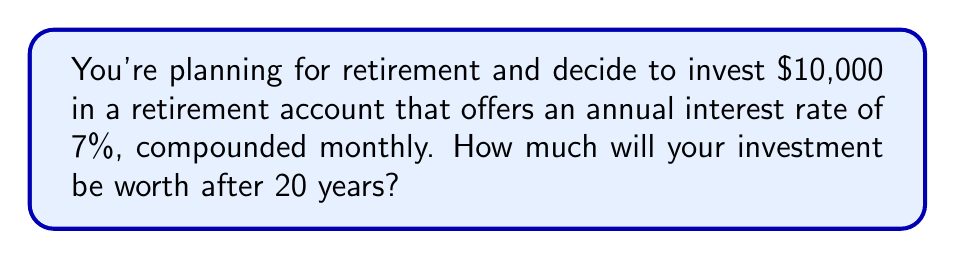Show me your answer to this math problem. To solve this problem, we'll use the compound interest formula:

$$A = P(1 + \frac{r}{n})^{nt}$$

Where:
$A$ = Final amount
$P$ = Principal (initial investment)
$r$ = Annual interest rate (as a decimal)
$n$ = Number of times interest is compounded per year
$t$ = Number of years

Given:
$P = \$10,000$
$r = 0.07$ (7% expressed as a decimal)
$n = 12$ (compounded monthly)
$t = 20$ years

Let's substitute these values into the formula:

$$A = 10000(1 + \frac{0.07}{12})^{12 \cdot 20}$$

$$A = 10000(1 + 0.005833)^{240}$$

$$A = 10000(1.005833)^{240}$$

Using a calculator:

$$A = 10000 \cdot 3.96991$$

$$A = 39699.10$$

Rounding to the nearest cent:

$$A = \$39,699.10$$
Answer: $39,699.10 